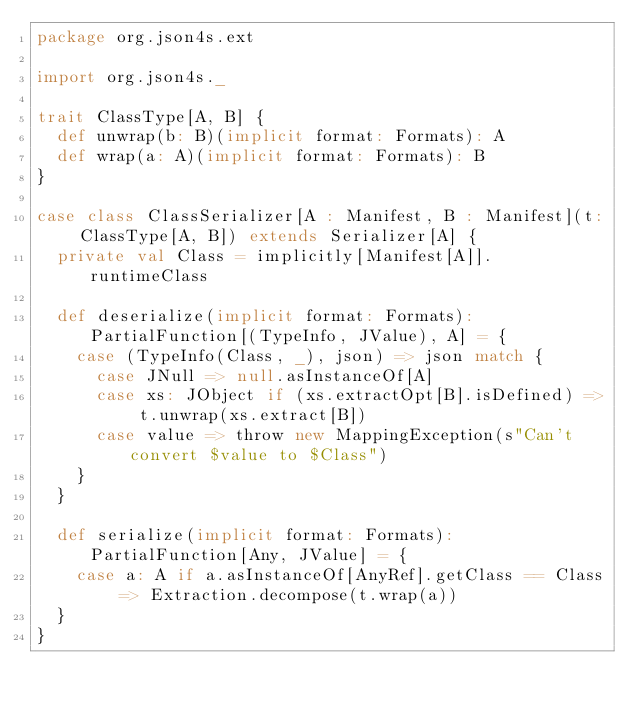<code> <loc_0><loc_0><loc_500><loc_500><_Scala_>package org.json4s.ext

import org.json4s._

trait ClassType[A, B] {
  def unwrap(b: B)(implicit format: Formats): A
  def wrap(a: A)(implicit format: Formats): B
}

case class ClassSerializer[A : Manifest, B : Manifest](t: ClassType[A, B]) extends Serializer[A] {
  private val Class = implicitly[Manifest[A]].runtimeClass

  def deserialize(implicit format: Formats): PartialFunction[(TypeInfo, JValue), A] = {
    case (TypeInfo(Class, _), json) => json match {
      case JNull => null.asInstanceOf[A]
      case xs: JObject if (xs.extractOpt[B].isDefined) => t.unwrap(xs.extract[B])
      case value => throw new MappingException(s"Can't convert $value to $Class")
    }
  }

  def serialize(implicit format: Formats): PartialFunction[Any, JValue] = {
    case a: A if a.asInstanceOf[AnyRef].getClass == Class => Extraction.decompose(t.wrap(a))
  }
}</code> 